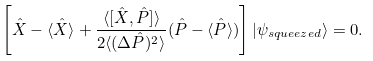<formula> <loc_0><loc_0><loc_500><loc_500>\left [ \hat { X } - \langle \hat { X } \rangle + \frac { \langle [ \hat { X } , \hat { P } ] \rangle } { 2 \langle ( \Delta \hat { P } ) ^ { 2 } \rangle } ( \hat { P } - \langle \hat { P } \rangle ) \right ] | \psi _ { s q u e e z e d } \rangle = 0 .</formula> 